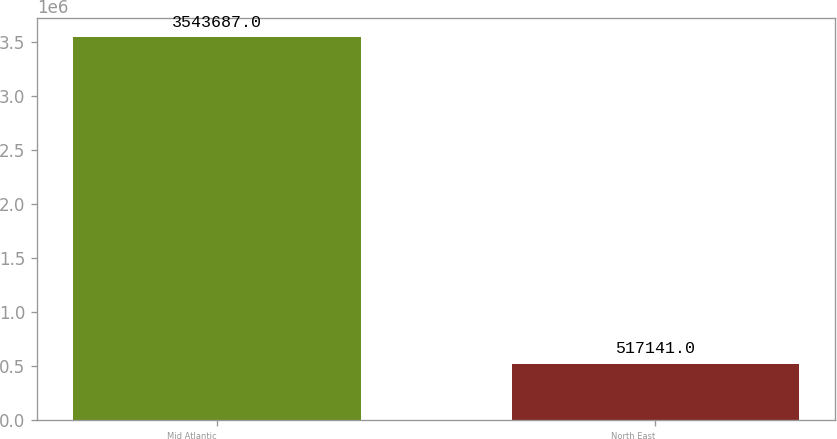Convert chart to OTSL. <chart><loc_0><loc_0><loc_500><loc_500><bar_chart><fcel>Mid Atlantic<fcel>North East<nl><fcel>3.54369e+06<fcel>517141<nl></chart> 